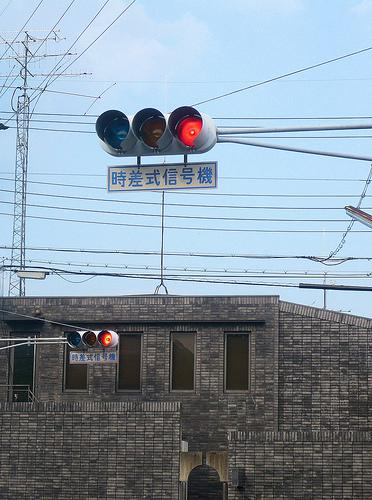Question: what is under the light?
Choices:
A. Car.
B. Tree.
C. Sign.
D. Cat.
Answer with the letter. Answer: C Question: what light is on?
Choices:
A. Green.
B. Street.
C. Table.
D. Red.
Answer with the letter. Answer: D Question: why is it red?
Choices:
A. Painted that way.
B. To capture attention.
C. Means stop.
D. School colors.
Answer with the letter. Answer: C Question: how fair is the weather?
Choices:
A. Not fair.
B. Cold.
C. Very fair.
D. Windy.
Answer with the letter. Answer: C Question: where is this scene?
Choices:
A. Hospital.
B. Street.
C. Restaurant.
D. Bedroom.
Answer with the letter. Answer: B 